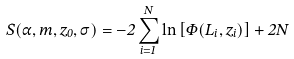Convert formula to latex. <formula><loc_0><loc_0><loc_500><loc_500>S ( \alpha , m , z _ { 0 } , \sigma ) = - 2 \sum _ { i = 1 } ^ { N } \ln \left [ \Phi ( L _ { i } , z _ { i } ) \right ] + 2 N</formula> 